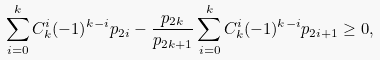Convert formula to latex. <formula><loc_0><loc_0><loc_500><loc_500>\sum _ { i = 0 } ^ { k } C _ { k } ^ { i } ( - 1 ) ^ { k - i } { p _ { 2 i } } - \frac { { p } _ { 2 k } } { p _ { 2 k + 1 } } \sum _ { i = 0 } ^ { k } C _ { k } ^ { i } ( - 1 ) ^ { k - i } { { p } _ { 2 i + 1 } } \geq 0 ,</formula> 